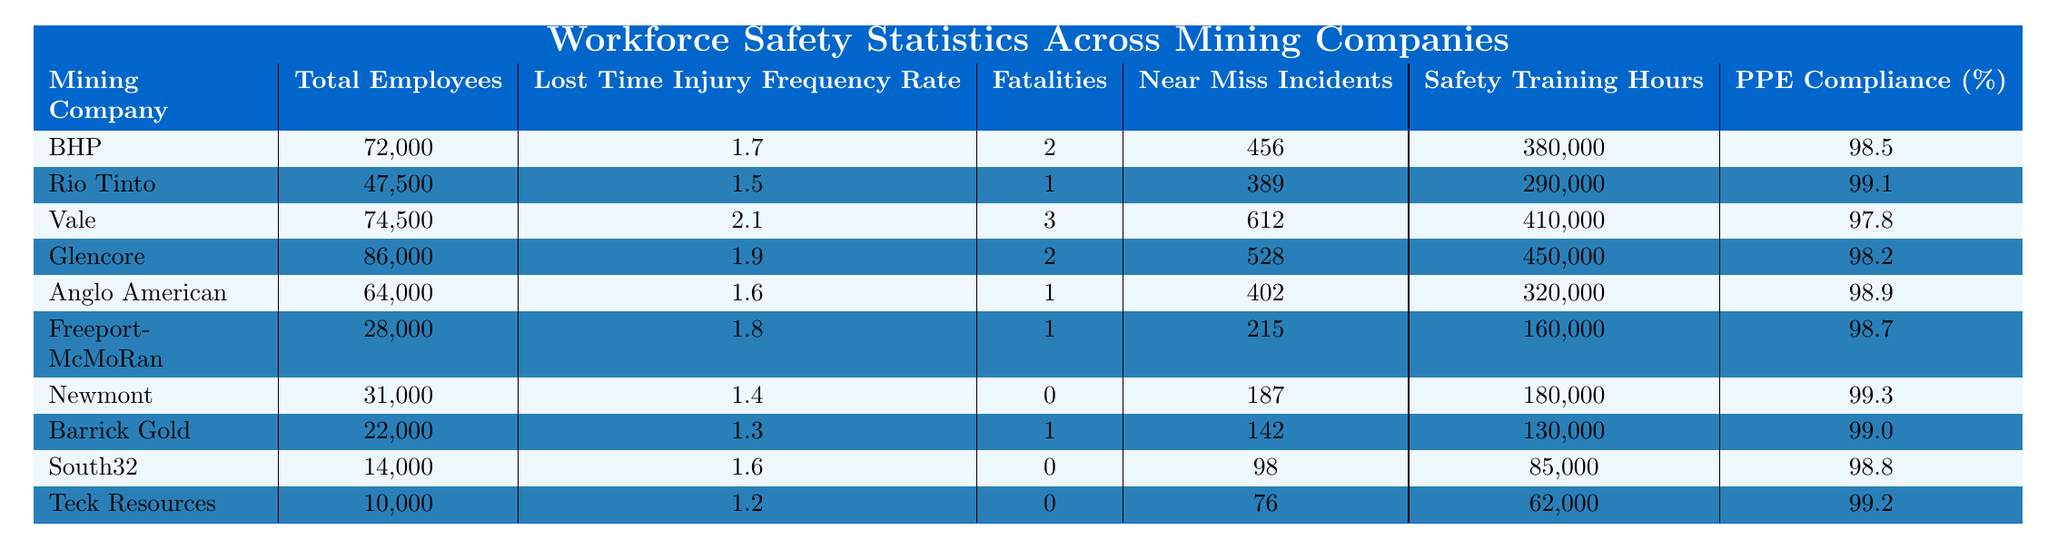What is the Lost Time Injury Frequency Rate for Newmont? According to the table, the Lost Time Injury Frequency Rate for Newmont is listed under that company, which is 1.4.
Answer: 1.4 Which mining company has the highest number of Near Miss Incidents? By comparing the values in the Near Miss Incidents column, Vale has the highest number with 612 incidents.
Answer: Vale How many fatalities were reported in total across all companies? To find the total fatalities, add the fatalities from each company: 2 + 1 + 3 + 2 + 1 + 1 + 0 + 1 + 0 + 0 = 12.
Answer: 12 What is the average number of Safety Training Hours among all companies? To calculate the average, sum the Safety Training Hours: 380,000 + 290,000 + 410,000 + 450,000 + 320,000 + 160,000 + 180,000 + 130,000 + 85,000 + 62,000 = 2,037,000. Then divide by the number of companies (10): 2,037,000 / 10 = 203,700.
Answer: 203,700 Which company shows the highest Personal Protective Equipment Compliance percentage? Looking at the PPE Compliance (%) column, Rio Tinto has the highest compliant percentage at 99.1%.
Answer: Rio Tinto Does Freeport-McMoRan have more or fewer safety training hours compared to Anglo American? Freeport-McMoRan has 160,000 training hours, while Anglo American has 320,000 hours, so Freeport-McMoRan has fewer training hours.
Answer: Fewer What is the difference in Lost Time Injury Frequency Rate between the company with the lowest rate and the highest rate? The lowest rate is from Newmont at 1.4 and the highest is from Vale at 2.1. The difference is 2.1 - 1.4 = 0.7.
Answer: 0.7 Identify the company with the least number of total employees. The table shows that Teck Resources has the least number of total employees at 10,000.
Answer: Teck Resources Is there any company that reported zero fatalities? By reviewing the Fatalities column, both Newmont and South32 reported zero fatalities.
Answer: Yes What percentage of companies reported less than 100 Near Miss Incidents? Looking at the Near Miss Incidents column, only Teck Resources and Newmont reported less than 100 incidents, which is 2 out of 10 companies. Thus, the percentage is (2/10) * 100 = 20%.
Answer: 20% 